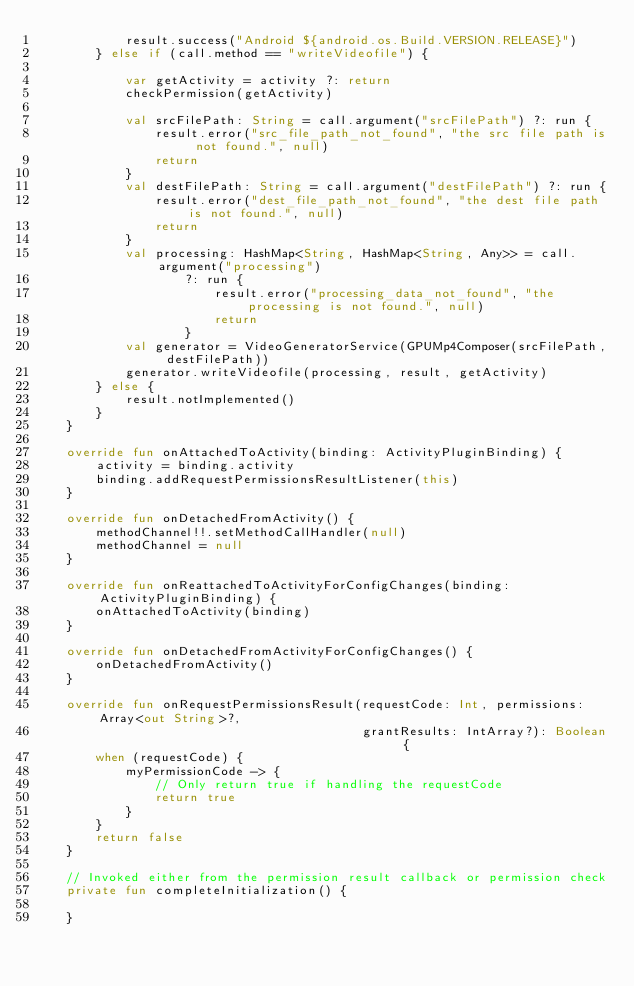Convert code to text. <code><loc_0><loc_0><loc_500><loc_500><_Kotlin_>            result.success("Android ${android.os.Build.VERSION.RELEASE}")
        } else if (call.method == "writeVideofile") {

            var getActivity = activity ?: return
            checkPermission(getActivity)

            val srcFilePath: String = call.argument("srcFilePath") ?: run {
                result.error("src_file_path_not_found", "the src file path is not found.", null)
                return
            }
            val destFilePath: String = call.argument("destFilePath") ?: run {
                result.error("dest_file_path_not_found", "the dest file path is not found.", null)
                return
            }
            val processing: HashMap<String, HashMap<String, Any>> = call.argument("processing")
                    ?: run {
                        result.error("processing_data_not_found", "the processing is not found.", null)
                        return
                    }
            val generator = VideoGeneratorService(GPUMp4Composer(srcFilePath, destFilePath))
            generator.writeVideofile(processing, result, getActivity)
        } else {
            result.notImplemented()
        }
    }

    override fun onAttachedToActivity(binding: ActivityPluginBinding) {
        activity = binding.activity
        binding.addRequestPermissionsResultListener(this)
    }

    override fun onDetachedFromActivity() {
        methodChannel!!.setMethodCallHandler(null)
        methodChannel = null
    }

    override fun onReattachedToActivityForConfigChanges(binding: ActivityPluginBinding) {
        onAttachedToActivity(binding)
    }

    override fun onDetachedFromActivityForConfigChanges() {
        onDetachedFromActivity()
    }

    override fun onRequestPermissionsResult(requestCode: Int, permissions: Array<out String>?,
                                            grantResults: IntArray?): Boolean {
        when (requestCode) {
            myPermissionCode -> {
                // Only return true if handling the requestCode
                return true
            }
        }
        return false
    }

    // Invoked either from the permission result callback or permission check
    private fun completeInitialization() {

    }
</code> 